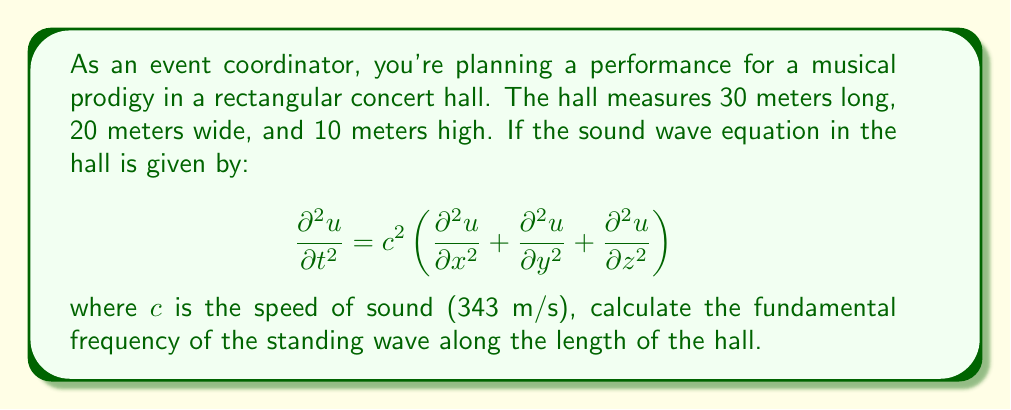Could you help me with this problem? To solve this problem, we'll follow these steps:

1) The fundamental frequency of a standing wave in a rectangular room is given by:

   $$f = \frac{c}{2L}$$

   where $c$ is the speed of sound and $L$ is the length of the room in the direction we're considering.

2) We're asked to find the fundamental frequency along the length of the hall, which is 30 meters.

3) Substituting the values into the equation:

   $$f = \frac{343 \text{ m/s}}{2(30 \text{ m})}$$

4) Simplify:

   $$f = \frac{343}{60} \text{ Hz}$$

5) Calculate:

   $$f \approx 5.72 \text{ Hz}$$

This frequency represents the lowest resonant frequency (or fundamental mode) of the concert hall along its length.
Answer: 5.72 Hz 